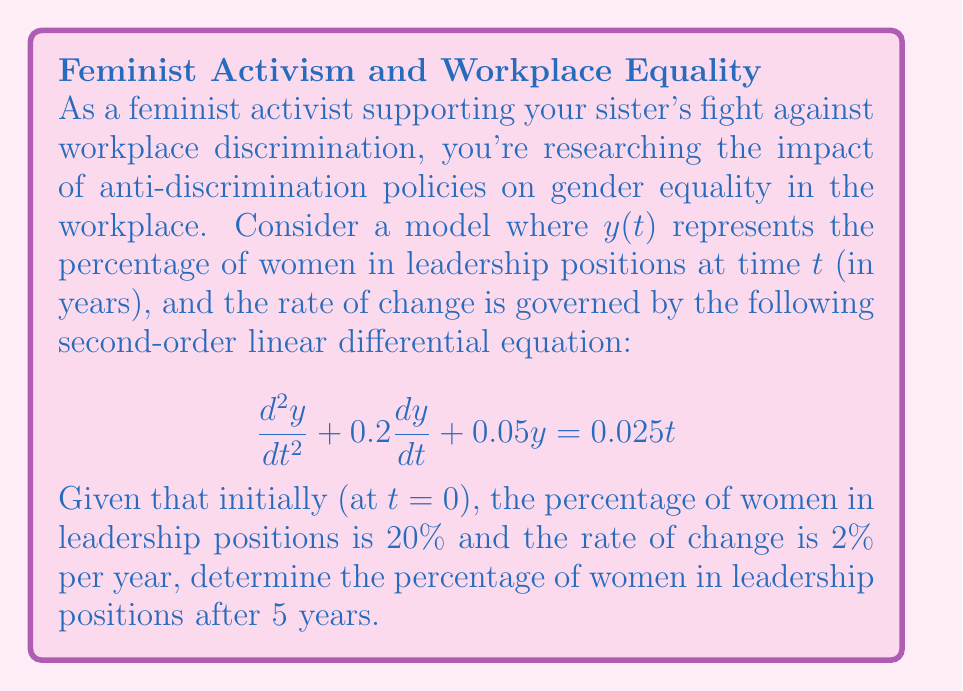Could you help me with this problem? To solve this problem, we'll follow these steps:

1) First, we need to solve the non-homogeneous second-order linear differential equation:

   $$\frac{d^2y}{dt^2} + 0.2\frac{dy}{dt} + 0.05y = 0.025t$$

2) The general solution will be of the form: $y(t) = y_c(t) + y_p(t)$, where $y_c(t)$ is the complementary solution and $y_p(t)$ is the particular solution.

3) For the complementary solution, we solve the characteristic equation:
   $r^2 + 0.2r + 0.05 = 0$
   $r = \frac{-0.2 \pm \sqrt{0.2^2 - 4(1)(0.05)}}{2(1)} = -0.1 \pm 0.2i$

   So, $y_c(t) = e^{-0.1t}(C_1\cos(0.2t) + C_2\sin(0.2t))$

4) For the particular solution, we assume $y_p(t) = At + B$:
   $A = 0.5$, $B = -2.5$
   So, $y_p(t) = 0.5t - 2.5$

5) The general solution is:
   $y(t) = e^{-0.1t}(C_1\cos(0.2t) + C_2\sin(0.2t)) + 0.5t - 2.5$

6) Using the initial conditions:
   At $t=0$: $y(0) = 0.2$ and $y'(0) = 0.02$

7) Solving for $C_1$ and $C_2$:
   $C_1 = 2.7$ and $C_2 = 0.6$

8) The final solution is:
   $y(t) = e^{-0.1t}(2.7\cos(0.2t) + 0.6\sin(0.2t)) + 0.5t - 2.5$

9) To find $y(5)$, we substitute $t=5$ into this equation:
   $y(5) \approx 0.2983$ or 29.83%
Answer: 29.83% 